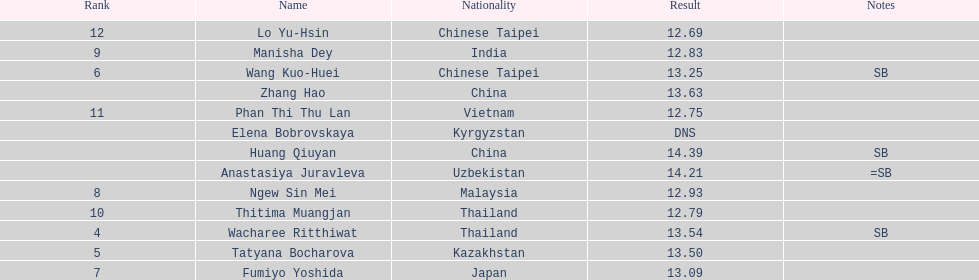How many athletes had a better result than tatyana bocharova? 4. 